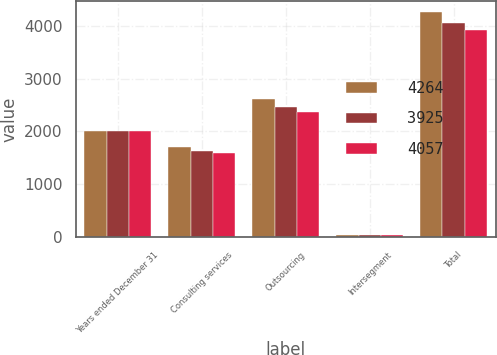Convert chart. <chart><loc_0><loc_0><loc_500><loc_500><stacked_bar_chart><ecel><fcel>Years ended December 31<fcel>Consulting services<fcel>Outsourcing<fcel>Intersegment<fcel>Total<nl><fcel>4264<fcel>2014<fcel>1700<fcel>2607<fcel>43<fcel>4264<nl><fcel>3925<fcel>2013<fcel>1626<fcel>2469<fcel>38<fcel>4057<nl><fcel>4057<fcel>2012<fcel>1585<fcel>2372<fcel>32<fcel>3925<nl></chart> 